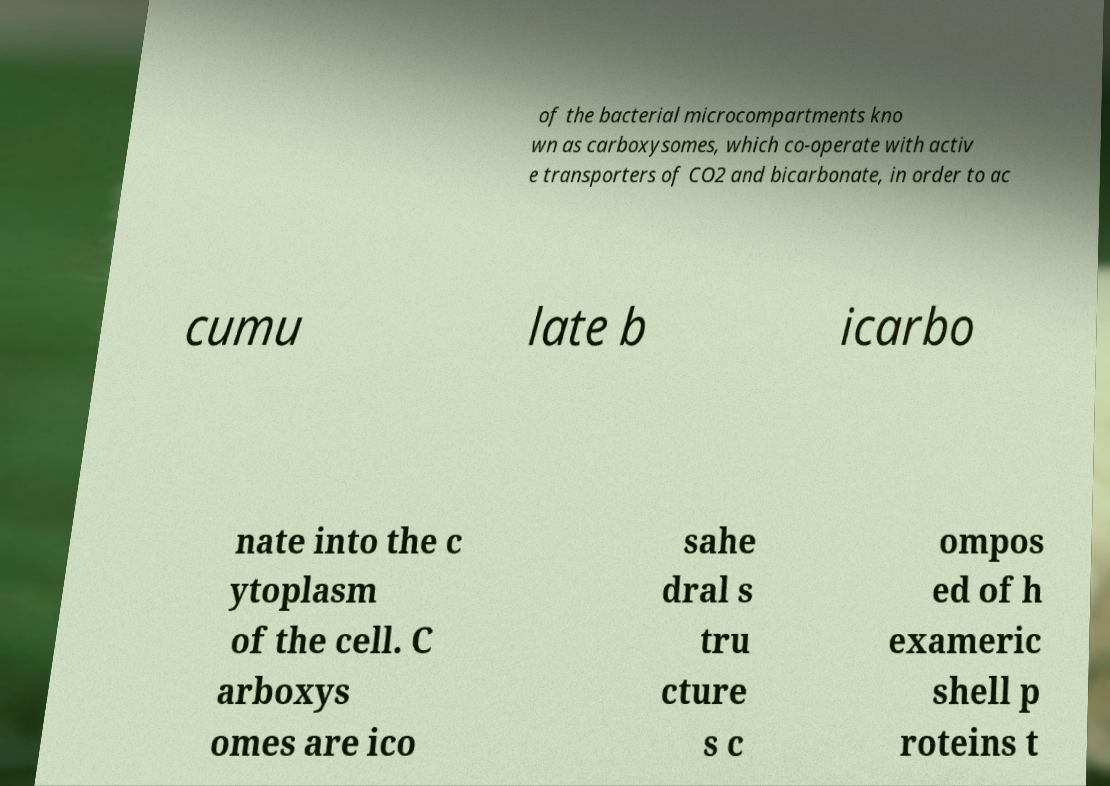Please identify and transcribe the text found in this image. of the bacterial microcompartments kno wn as carboxysomes, which co-operate with activ e transporters of CO2 and bicarbonate, in order to ac cumu late b icarbo nate into the c ytoplasm of the cell. C arboxys omes are ico sahe dral s tru cture s c ompos ed of h exameric shell p roteins t 